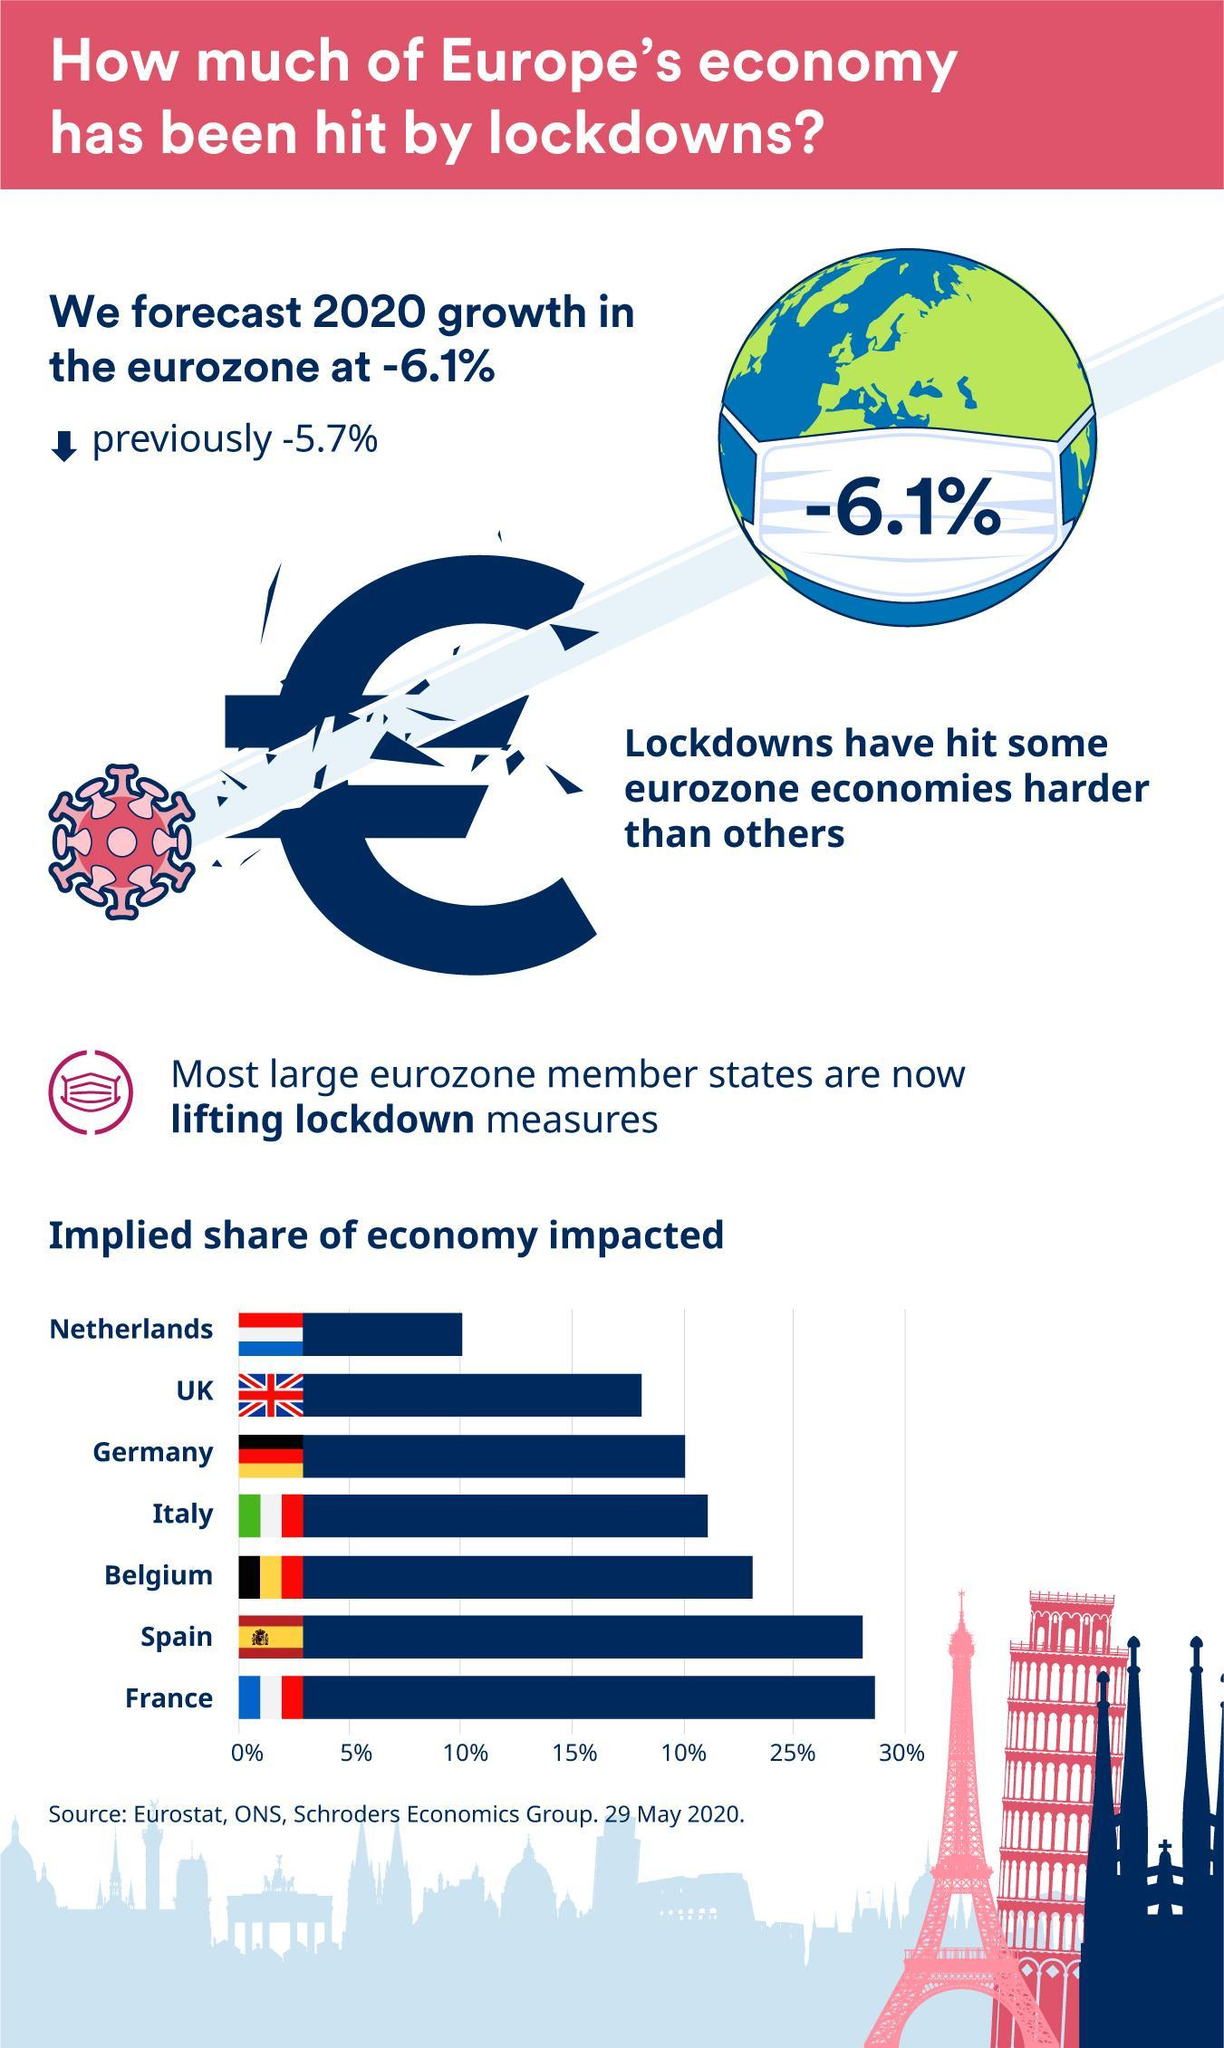what is printed on the mask
Answer the question with a short phrase. -6.1% Which countries economy has been impacted over 25% Spain, France What is the colour of the Eiffel tower, pink or blue pink Which countries flags have the same colour combination of red, white and blue Netherlands, UK, France Which countries economy has the second lowest impact UK 